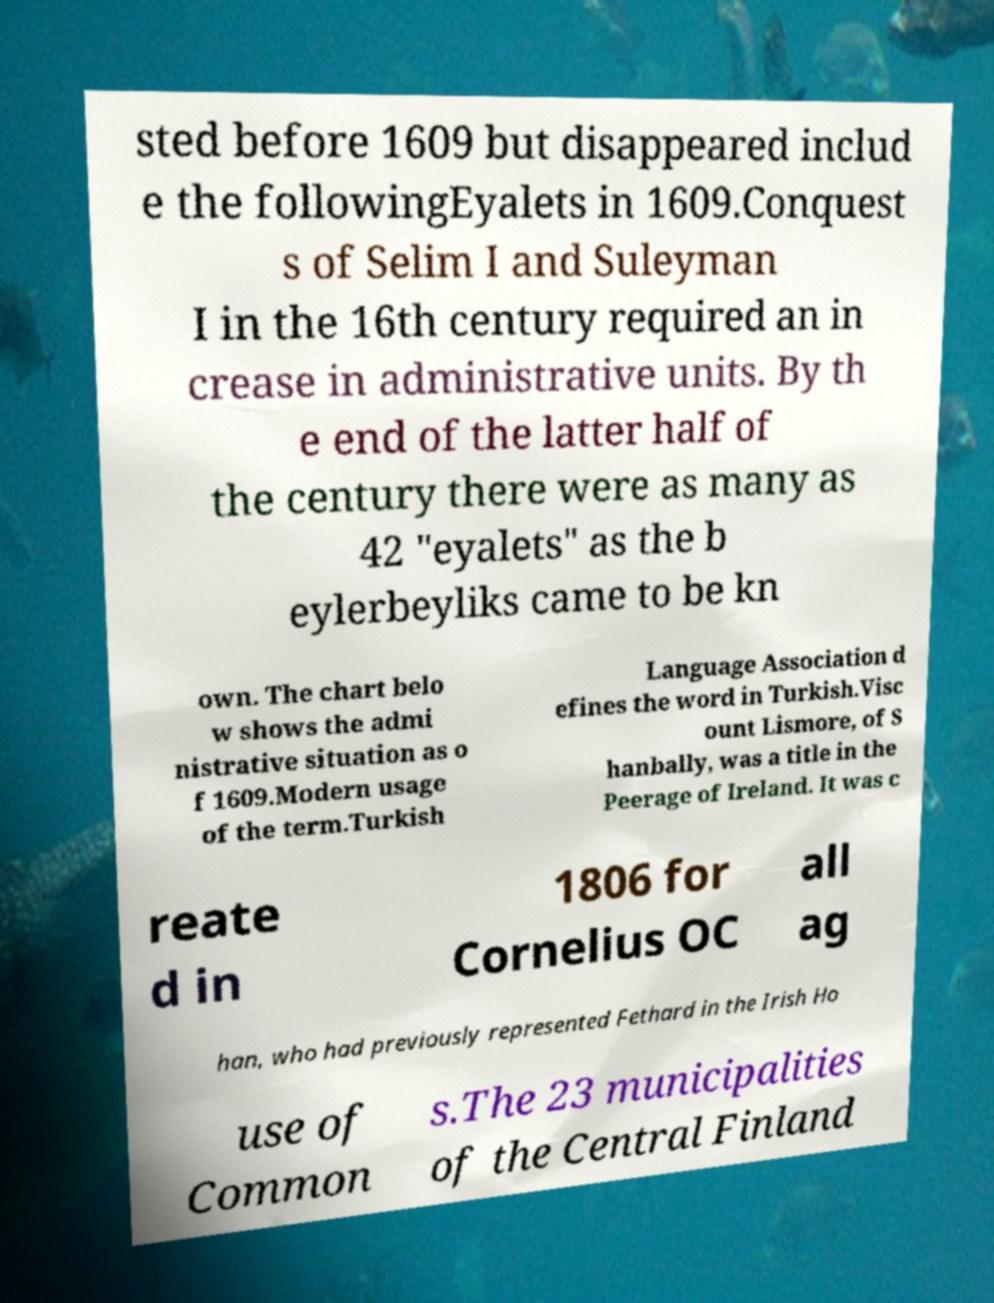Could you extract and type out the text from this image? sted before 1609 but disappeared includ e the followingEyalets in 1609.Conquest s of Selim I and Suleyman I in the 16th century required an in crease in administrative units. By th e end of the latter half of the century there were as many as 42 "eyalets" as the b eylerbeyliks came to be kn own. The chart belo w shows the admi nistrative situation as o f 1609.Modern usage of the term.Turkish Language Association d efines the word in Turkish.Visc ount Lismore, of S hanbally, was a title in the Peerage of Ireland. It was c reate d in 1806 for Cornelius OC all ag han, who had previously represented Fethard in the Irish Ho use of Common s.The 23 municipalities of the Central Finland 